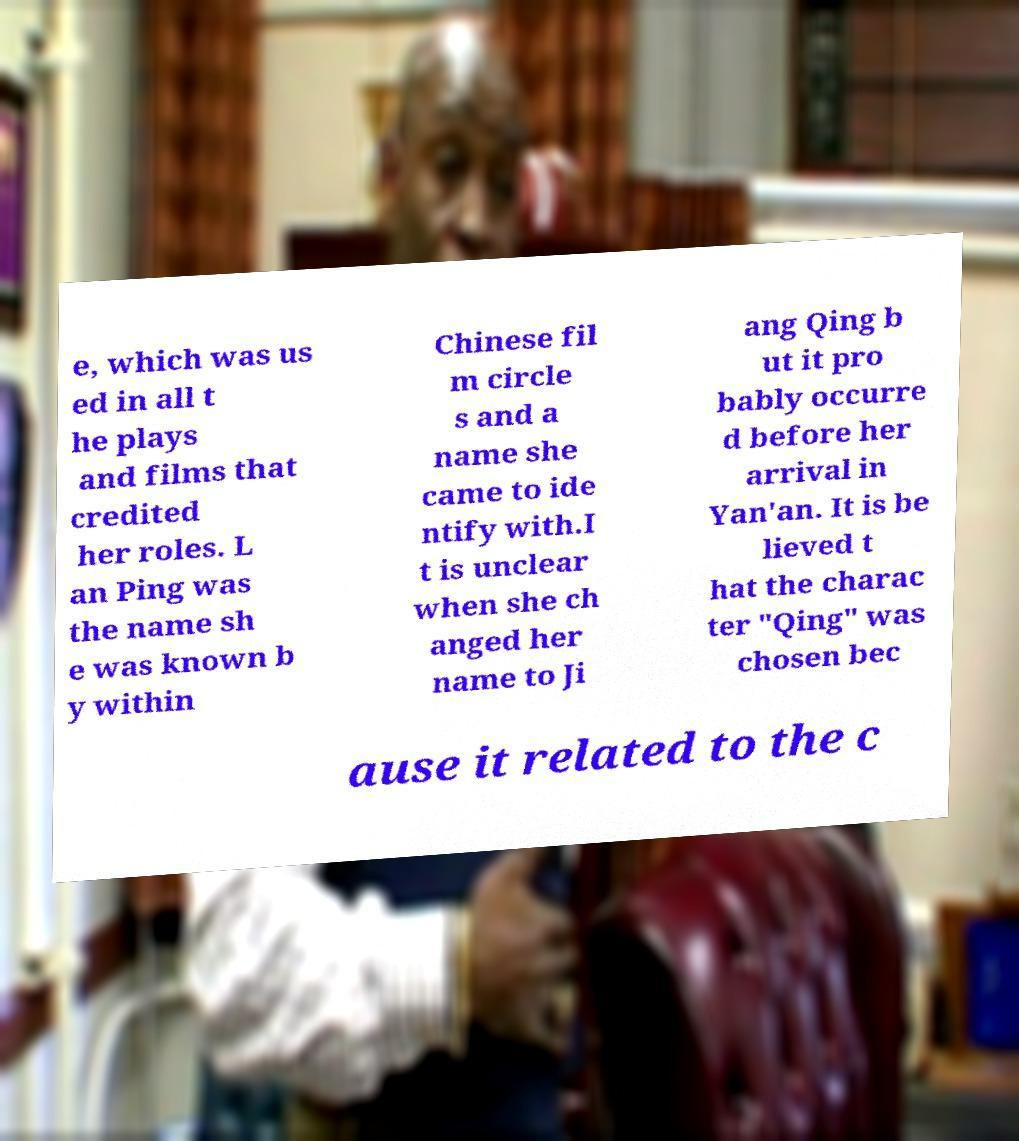Can you accurately transcribe the text from the provided image for me? e, which was us ed in all t he plays and films that credited her roles. L an Ping was the name sh e was known b y within Chinese fil m circle s and a name she came to ide ntify with.I t is unclear when she ch anged her name to Ji ang Qing b ut it pro bably occurre d before her arrival in Yan'an. It is be lieved t hat the charac ter "Qing" was chosen bec ause it related to the c 